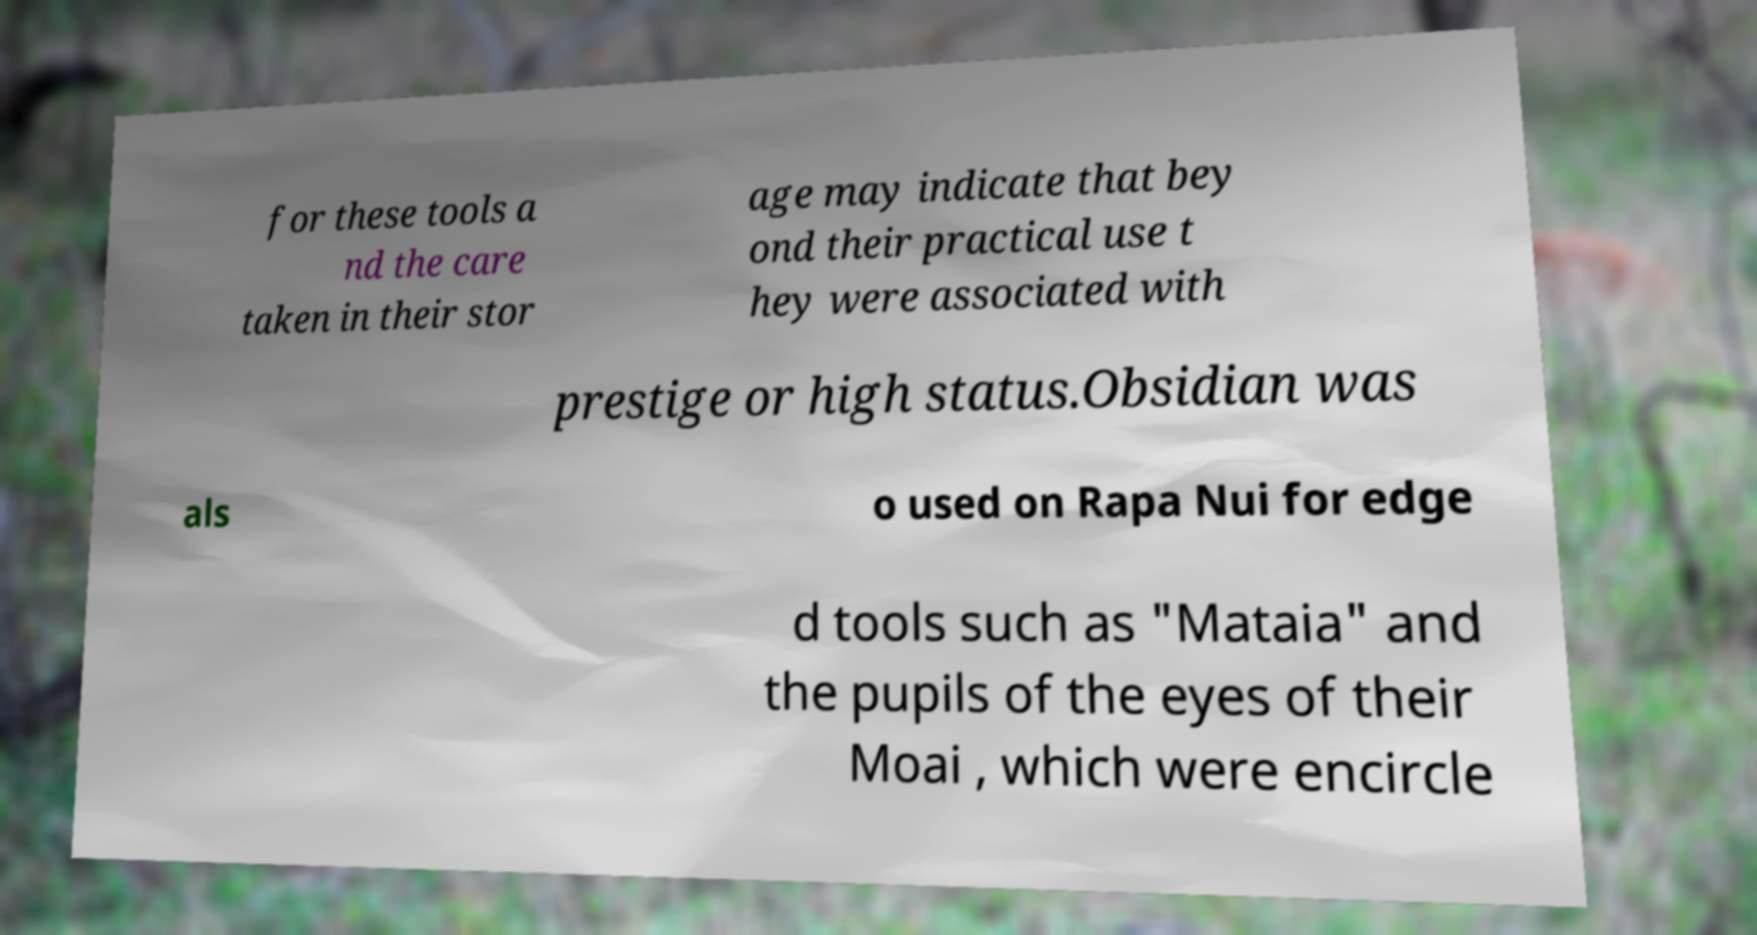I need the written content from this picture converted into text. Can you do that? for these tools a nd the care taken in their stor age may indicate that bey ond their practical use t hey were associated with prestige or high status.Obsidian was als o used on Rapa Nui for edge d tools such as "Mataia" and the pupils of the eyes of their Moai , which were encircle 